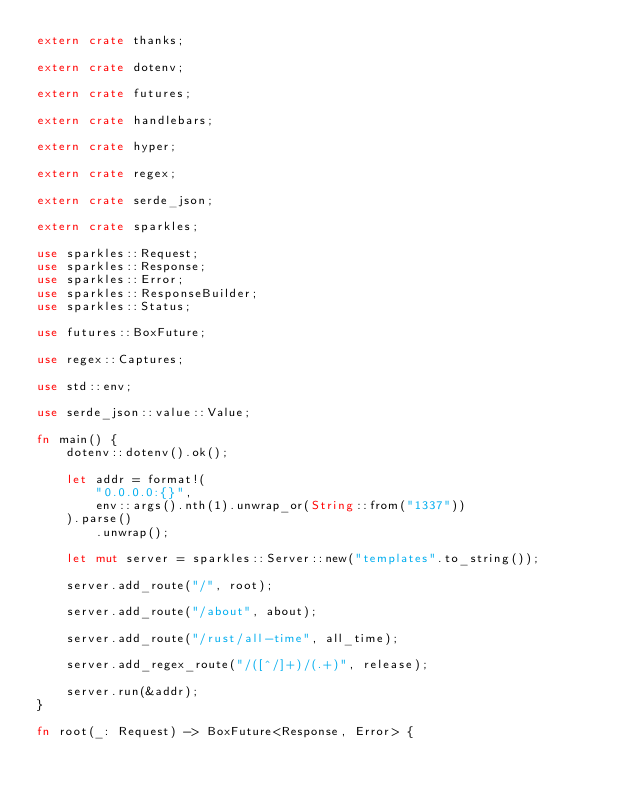<code> <loc_0><loc_0><loc_500><loc_500><_Rust_>extern crate thanks;

extern crate dotenv;

extern crate futures;

extern crate handlebars;

extern crate hyper;

extern crate regex;

extern crate serde_json;

extern crate sparkles;

use sparkles::Request;
use sparkles::Response;
use sparkles::Error;
use sparkles::ResponseBuilder;
use sparkles::Status;

use futures::BoxFuture;

use regex::Captures;

use std::env;

use serde_json::value::Value;

fn main() {
    dotenv::dotenv().ok();

    let addr = format!(
        "0.0.0.0:{}",
        env::args().nth(1).unwrap_or(String::from("1337"))
    ).parse()
        .unwrap();

    let mut server = sparkles::Server::new("templates".to_string());

    server.add_route("/", root);

    server.add_route("/about", about);

    server.add_route("/rust/all-time", all_time);

    server.add_regex_route("/([^/]+)/(.+)", release);

    server.run(&addr);
}

fn root(_: Request) -> BoxFuture<Response, Error> {</code> 